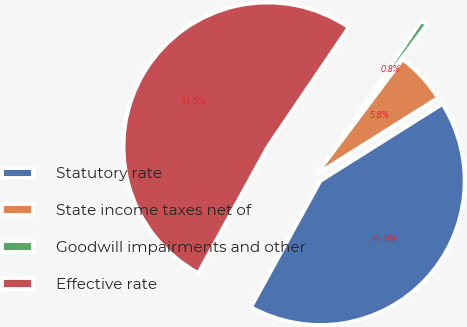Convert chart to OTSL. <chart><loc_0><loc_0><loc_500><loc_500><pie_chart><fcel>Statutory rate<fcel>State income taxes net of<fcel>Goodwill impairments and other<fcel>Effective rate<nl><fcel>41.94%<fcel>5.82%<fcel>0.75%<fcel>51.49%<nl></chart> 